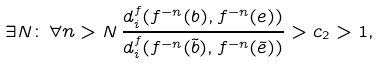<formula> <loc_0><loc_0><loc_500><loc_500>\exists N \colon \, \forall n > N \, \frac { d _ { i } ^ { f } ( f ^ { - n } ( b ) , f ^ { - n } ( e ) ) } { d _ { i } ^ { f } ( f ^ { - n } ( \tilde { b } ) , f ^ { - n } ( \tilde { e } ) ) } > c _ { 2 } > 1 ,</formula> 